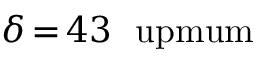Convert formula to latex. <formula><loc_0><loc_0><loc_500><loc_500>{ \delta } \, { = } \, 4 3 \ u p m u m</formula> 